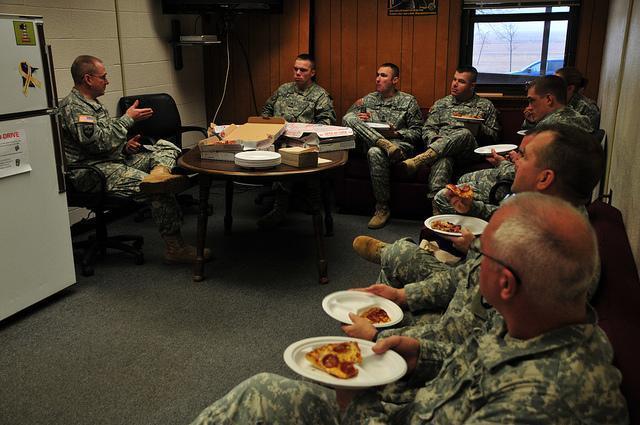What are they doing?
Choose the right answer from the provided options to respond to the question.
Options: Answering questions, arguing, eating pizza, resting. Eating pizza. 